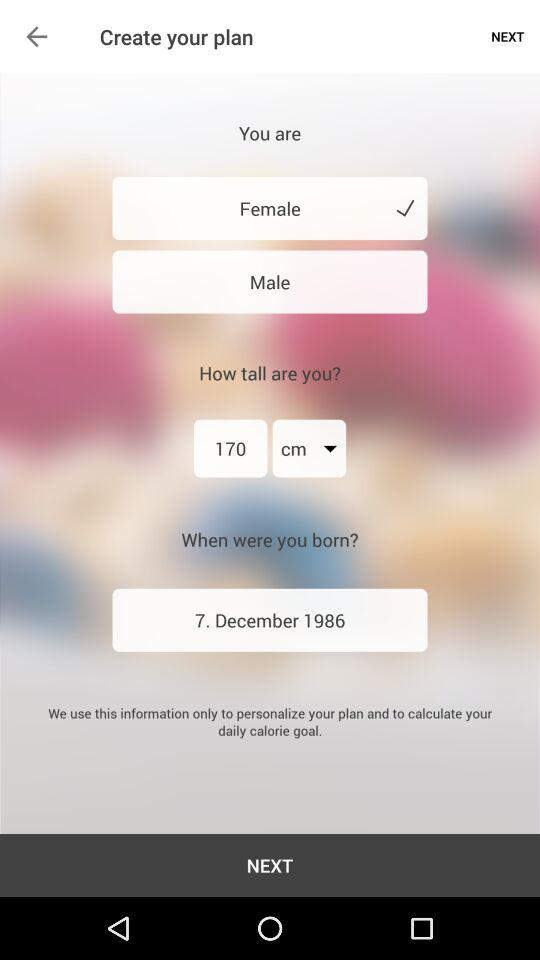What is the date of birth? The date of birth is December 7, 1986. 